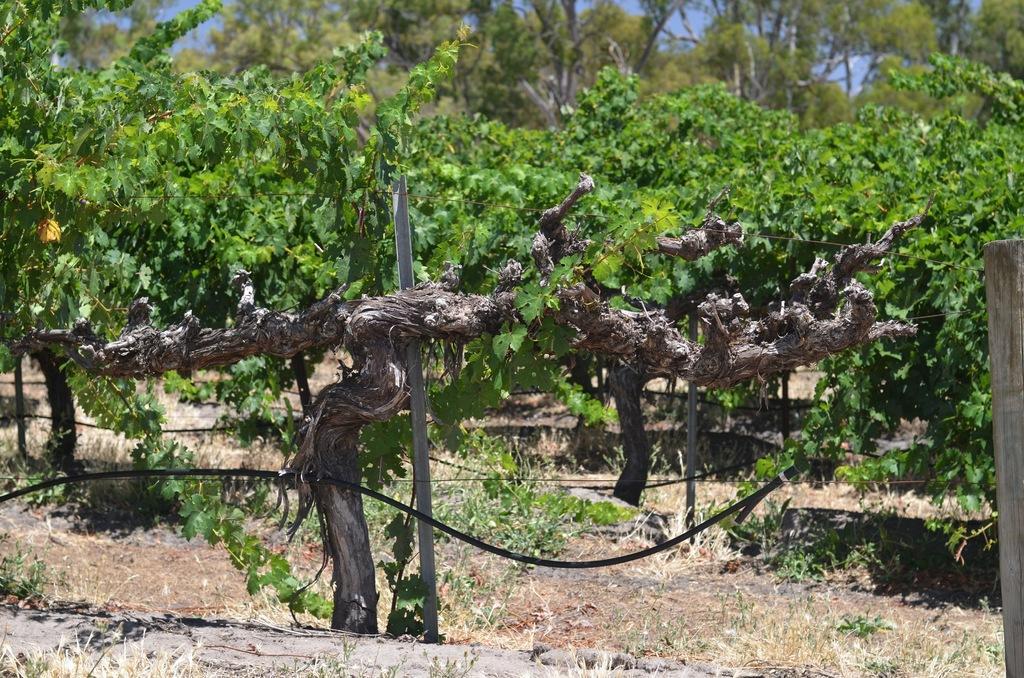Describe this image in one or two sentences. In this image, we can see some trees and plants. There is a pole and pipe in the middle of the image. 